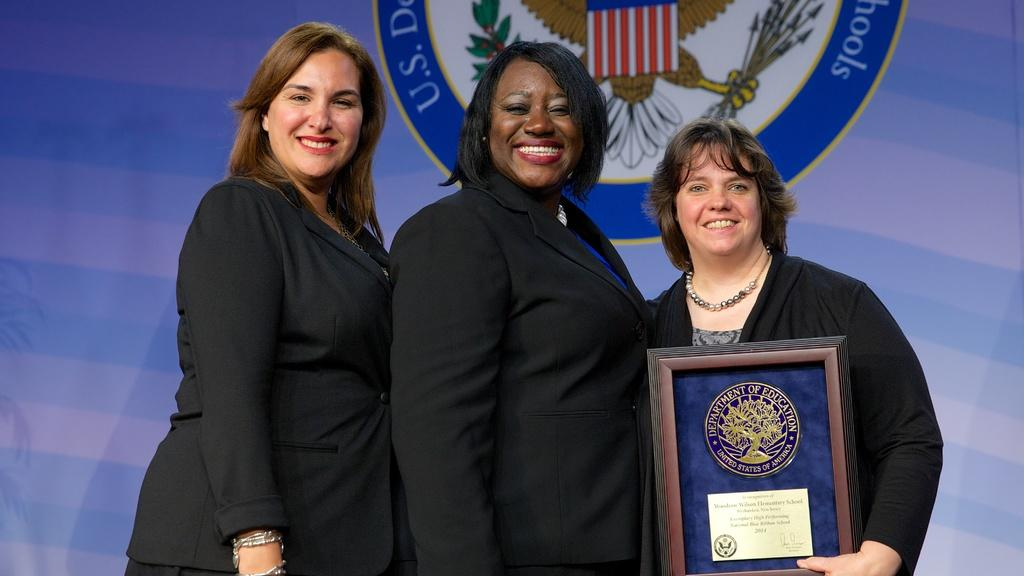Who is present in the image? There are women in the image. What are the women doing in the image? The women are smiling. Can you describe any specific actions or objects in the image? One woman is holding an award. What can be seen in the background of the image? There is a curtain in the background of the image. What are the hobbies of the women in the image? The provided facts do not mention the hobbies of the women, so we cannot determine their hobbies from the image. How many women are holding an award in the image? The provided facts only mention one woman holding an award, so we cannot determine if there is a fifth woman holding an award. 